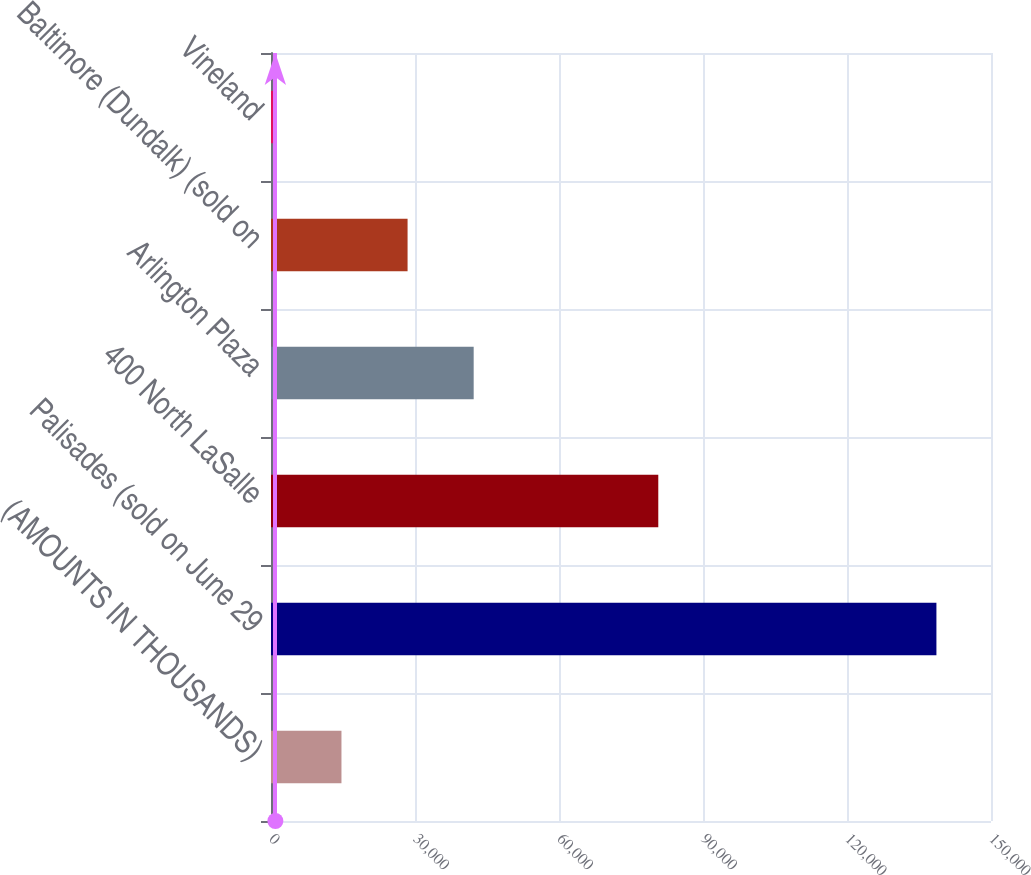Convert chart to OTSL. <chart><loc_0><loc_0><loc_500><loc_500><bar_chart><fcel>(AMOUNTS IN THOUSANDS)<fcel>Palisades (sold on June 29<fcel>400 North LaSalle<fcel>Arlington Plaza<fcel>Baltimore (Dundalk) (sold on<fcel>Vineland<nl><fcel>14680.1<fcel>138629<fcel>80685<fcel>42224.3<fcel>28452.2<fcel>908<nl></chart> 